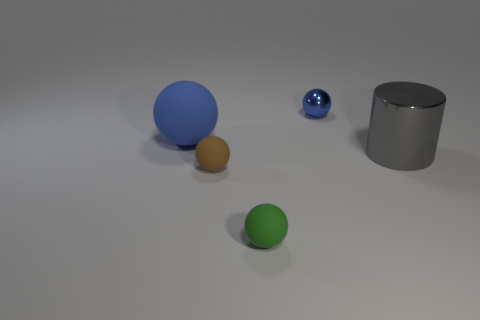What might the context or purpose of this arrangement be? It appears to be a controlled setting possibly set up for demonstrating the concepts of size, color, and material contrast, or it might be an artist's composition for a still life study. 